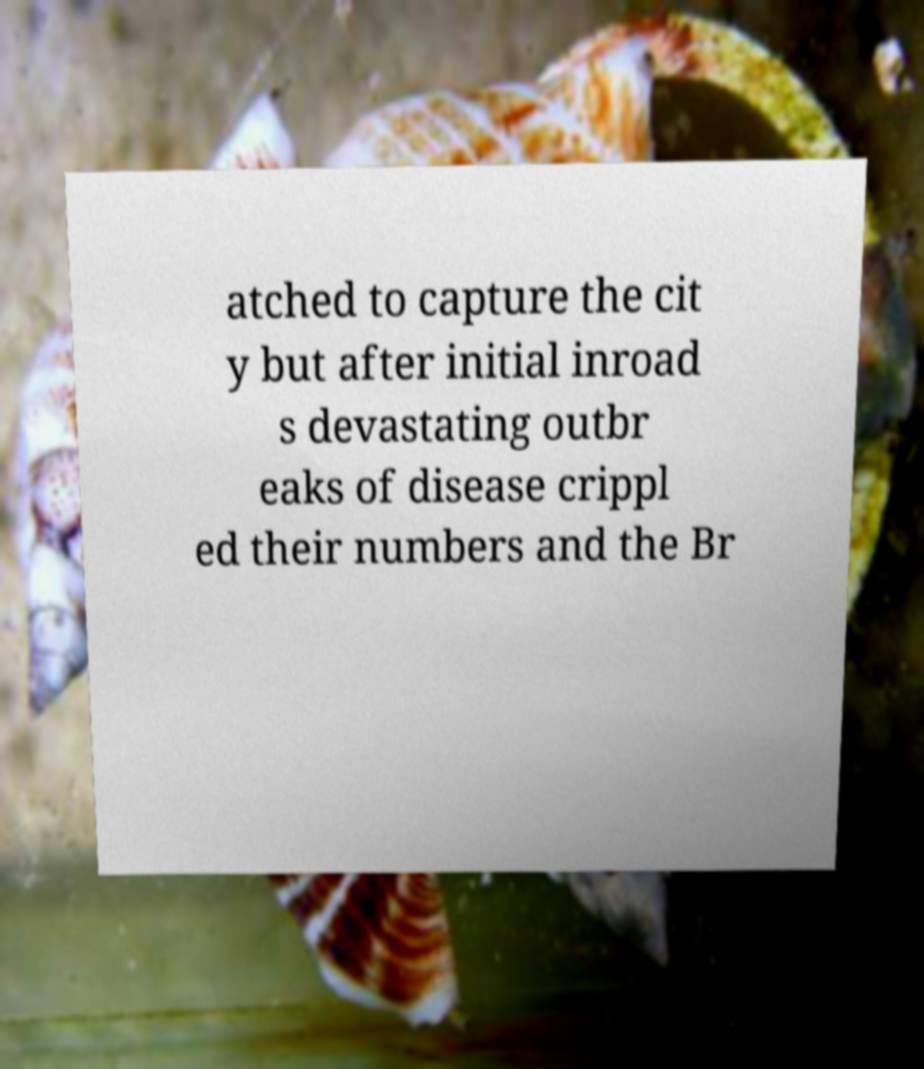Could you assist in decoding the text presented in this image and type it out clearly? atched to capture the cit y but after initial inroad s devastating outbr eaks of disease crippl ed their numbers and the Br 